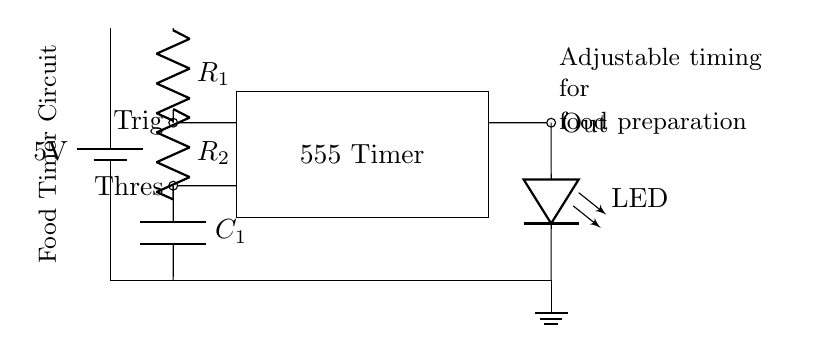What is the main component used in this circuit? The main component of this circuit is the 555 Timer, which is a versatile integrated circuit used for timing applications. You can identify it in the diagram as the rectangular block labeled "555 Timer."
Answer: 555 Timer What do R1 and R2 represent? R1 and R2 are resistors in the circuit that determine the timing intervals for the 555 Timer. They are labeled next to the vertical lines connected to the battery and other components.
Answer: Resistors What is the purpose of the capacitor C1? The capacitor C1 is used to store and release electrical energy, affecting the timing duration. It's connected to the output circuit of the timer and influences the timing cycle of the 555 Timer by charging and discharging.
Answer: Store energy What is the output of the timer connected to? The output of the timer is connected to an LED, which indicates when the timer activates. You can see a direct connection from the "Out" terminal of the 555 Timer to the LED symbol in the diagram.
Answer: LED How can you adjust the timing for food preparation? The timing can be adjusted by changing the values of resistors R1 and R2, as well as the capacitance of capacitor C1. The timing interval is generally proportional to the resistance and capacitance values used in the circuit.
Answer: Change R1, R2, C1 What is the voltage supply for this circuit? The voltage supply for this circuit is 5 volts, as indicated by the battery symbol at the top left of the schematic. It provides the necessary power for the circuit to operate.
Answer: 5 volts What does the ground symbol indicate in the circuit? The ground symbol indicates the reference point in the circuit where all voltages are measured. It is a common return path for electric current and completes the circuit loop for all components.
Answer: Reference point 